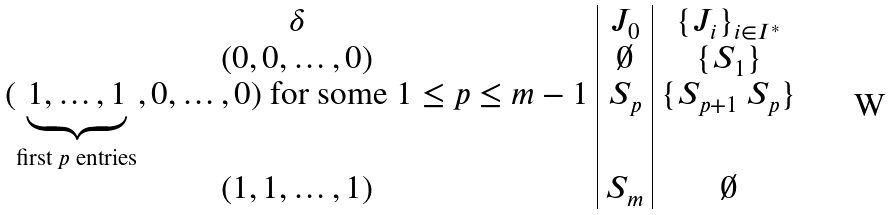Convert formula to latex. <formula><loc_0><loc_0><loc_500><loc_500>\begin{array} { c | c | c } \delta & J _ { 0 } & \{ J _ { i } \} _ { i \in I ^ { * } } \\ ( 0 , 0 , \dots , 0 ) & \emptyset & \{ S _ { 1 } \} \\ ( \underbrace { 1 , \dots , 1 } _ { \text {first $p$ entries} } , 0 , \dots , 0 ) \text { for some $1\leq p\leq m-1$} & S _ { p } & \{ S _ { p + 1 } \ S _ { p } \} \\ ( 1 , 1 , \dots , 1 ) & S _ { m } & \emptyset \end{array}</formula> 